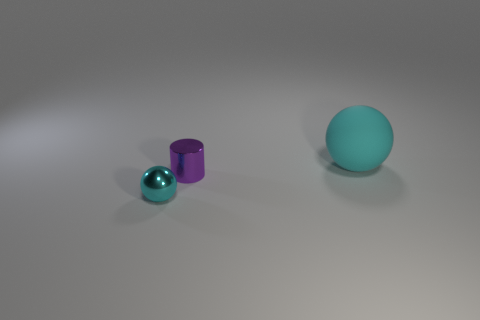Are there any other things that are the same color as the small ball?
Your answer should be very brief. Yes. There is a cyan thing in front of the large cyan object; does it have the same shape as the purple object behind the shiny sphere?
Your response must be concise. No. Is there any other thing that has the same material as the large ball?
Make the answer very short. No. There is a small thing right of the cyan sphere that is in front of the cyan sphere on the right side of the small cyan metal thing; what shape is it?
Make the answer very short. Cylinder. What number of other objects are the same shape as the small cyan metal object?
Give a very brief answer. 1. There is a ball that is the same size as the metal cylinder; what is its color?
Your answer should be very brief. Cyan. What number of cylinders are small purple shiny objects or matte objects?
Give a very brief answer. 1. What number of balls are there?
Your response must be concise. 2. There is a cyan matte thing; is it the same shape as the tiny shiny thing that is in front of the small cylinder?
Give a very brief answer. Yes. There is another sphere that is the same color as the large rubber sphere; what is its size?
Offer a very short reply. Small. 